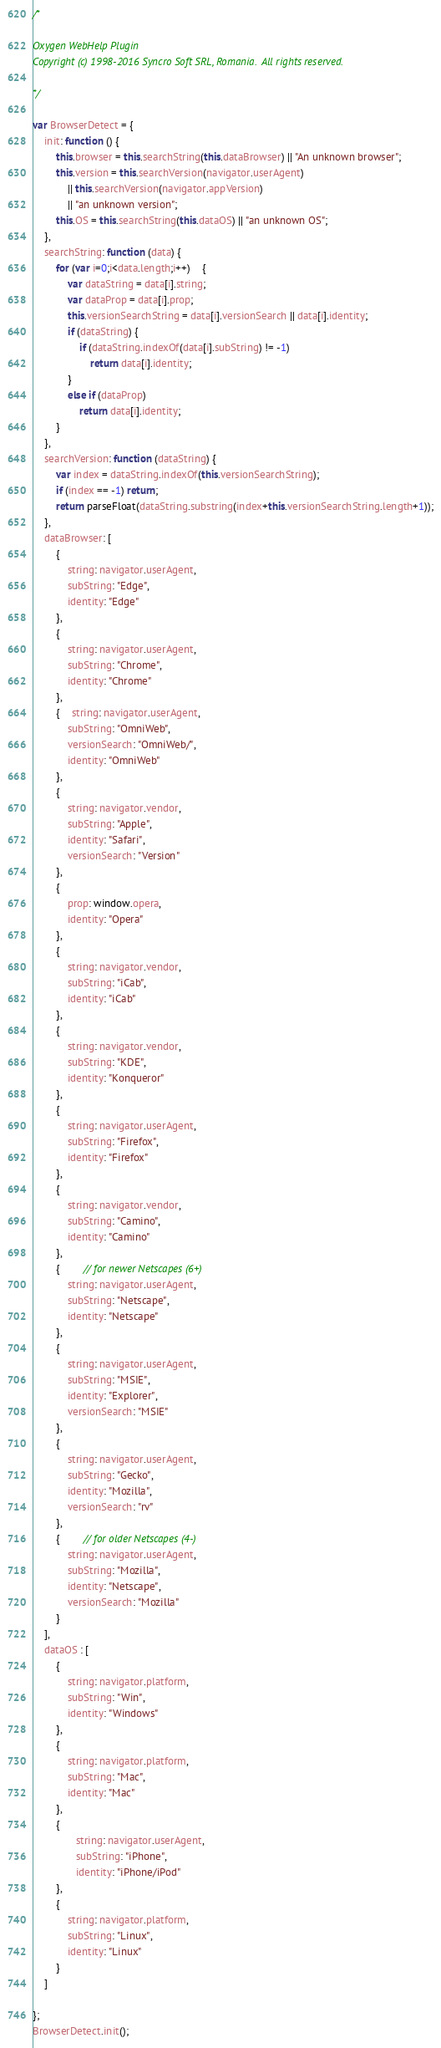<code> <loc_0><loc_0><loc_500><loc_500><_JavaScript_>/*

Oxygen WebHelp Plugin
Copyright (c) 1998-2016 Syncro Soft SRL, Romania.  All rights reserved.

*/

var BrowserDetect = {
	init: function () {
		this.browser = this.searchString(this.dataBrowser) || "An unknown browser";
		this.version = this.searchVersion(navigator.userAgent)
			|| this.searchVersion(navigator.appVersion)
			|| "an unknown version";
		this.OS = this.searchString(this.dataOS) || "an unknown OS";
	},
	searchString: function (data) {
		for (var i=0;i<data.length;i++)	{
			var dataString = data[i].string;
			var dataProp = data[i].prop;
			this.versionSearchString = data[i].versionSearch || data[i].identity;
			if (dataString) {
				if (dataString.indexOf(data[i].subString) != -1)
					return data[i].identity;
			}
			else if (dataProp)
				return data[i].identity;
		}
	},
	searchVersion: function (dataString) {
		var index = dataString.indexOf(this.versionSearchString);
		if (index == -1) return;
		return parseFloat(dataString.substring(index+this.versionSearchString.length+1));
	},
	dataBrowser: [
		{
			string: navigator.userAgent,
			subString: "Edge",
			identity: "Edge"
		},
		{
			string: navigator.userAgent,
			subString: "Chrome",
			identity: "Chrome"
		},
		{ 	string: navigator.userAgent,
			subString: "OmniWeb",
			versionSearch: "OmniWeb/",
			identity: "OmniWeb"
		},
		{
			string: navigator.vendor,
			subString: "Apple",
			identity: "Safari",
			versionSearch: "Version"
		},
		{
			prop: window.opera,
			identity: "Opera"
		},
		{
			string: navigator.vendor,
			subString: "iCab",
			identity: "iCab"
		},
		{
			string: navigator.vendor,
			subString: "KDE",
			identity: "Konqueror"
		},
		{
			string: navigator.userAgent,
			subString: "Firefox",
			identity: "Firefox"
		},
		{
			string: navigator.vendor,
			subString: "Camino",
			identity: "Camino"
		},
		{		// for newer Netscapes (6+)
			string: navigator.userAgent,
			subString: "Netscape",
			identity: "Netscape"
		},
		{
			string: navigator.userAgent,
			subString: "MSIE",
			identity: "Explorer",
			versionSearch: "MSIE"
		},
		{
			string: navigator.userAgent,
			subString: "Gecko",
			identity: "Mozilla",
			versionSearch: "rv"
		},
		{ 		// for older Netscapes (4-)
			string: navigator.userAgent,
			subString: "Mozilla",
			identity: "Netscape",
			versionSearch: "Mozilla"
		}
	],
	dataOS : [
		{
			string: navigator.platform,
			subString: "Win",
			identity: "Windows"
		},
		{
			string: navigator.platform,
			subString: "Mac",
			identity: "Mac"
		},
		{
			   string: navigator.userAgent,
			   subString: "iPhone",
			   identity: "iPhone/iPod"
	    },
		{
			string: navigator.platform,
			subString: "Linux",
			identity: "Linux"
		}
	]

};
BrowserDetect.init();</code> 